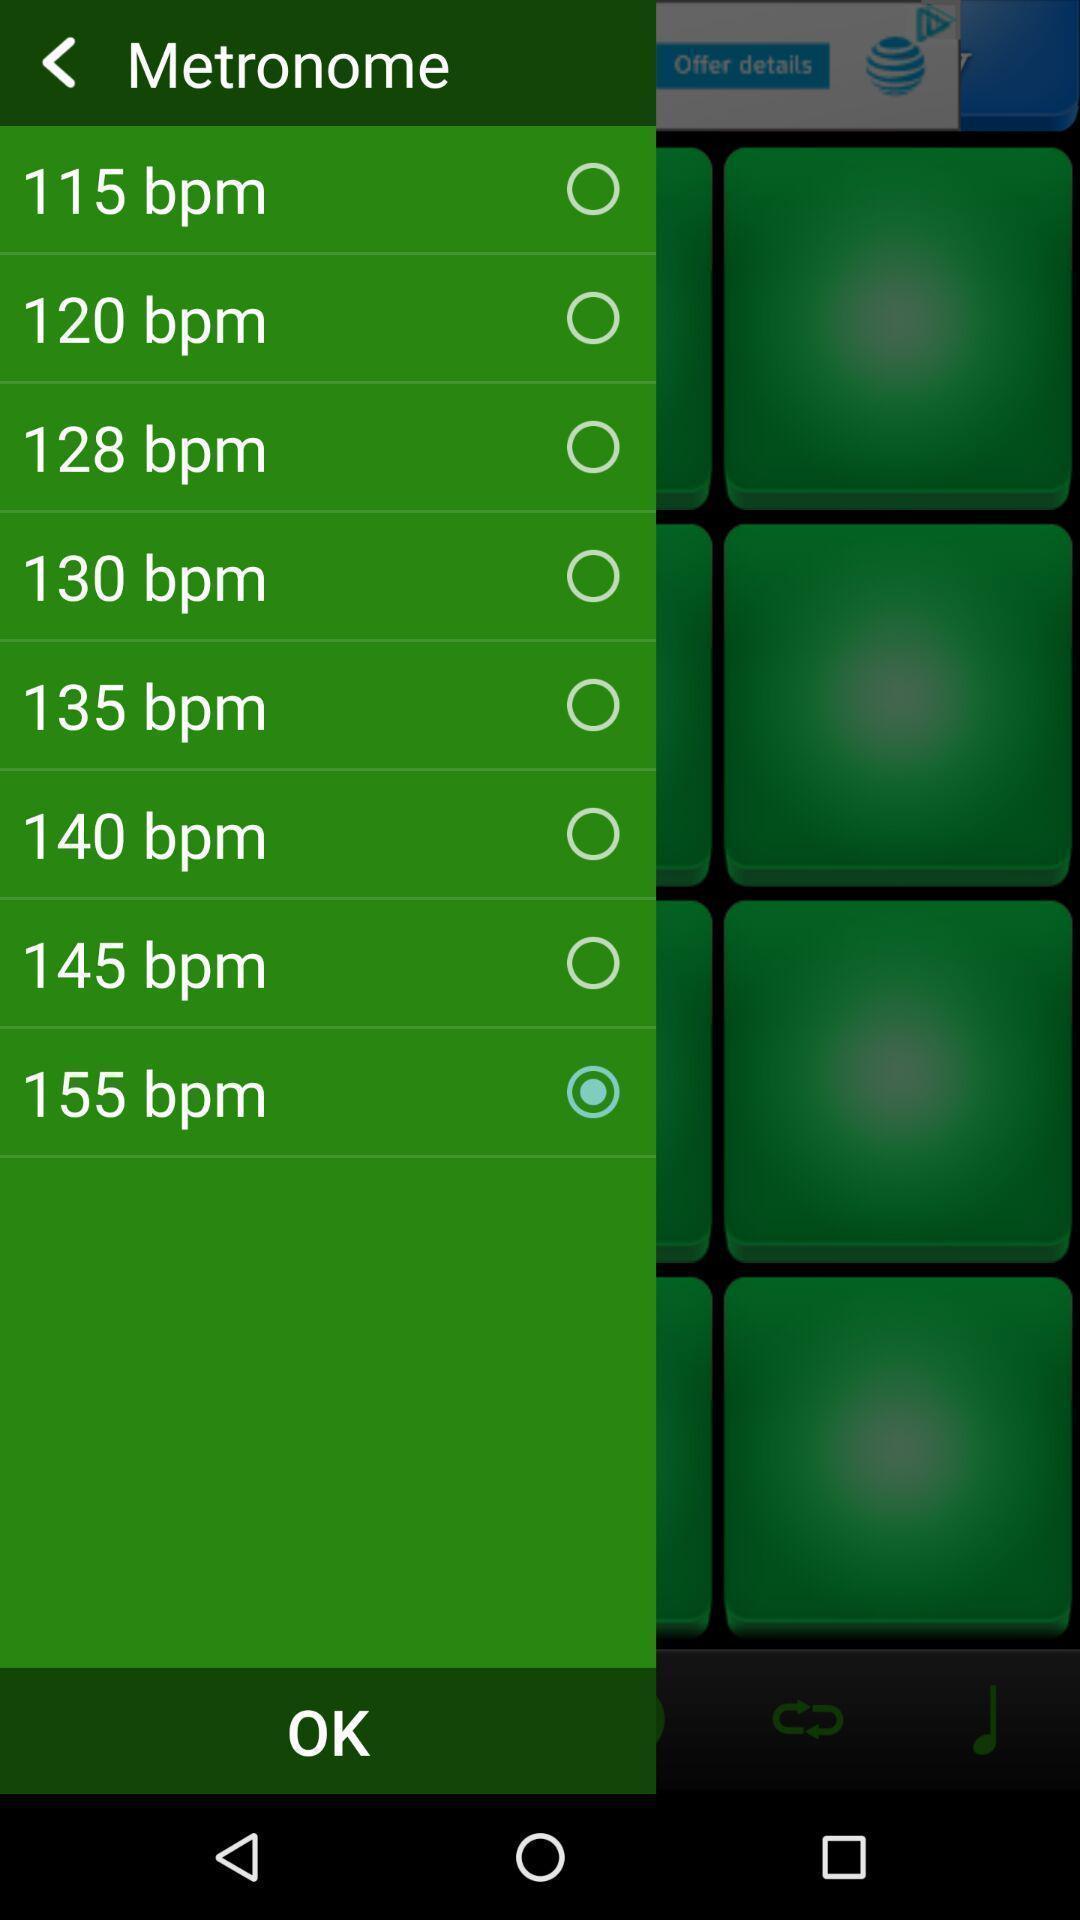Tell me what you see in this picture. Page showing different options in metronome. 